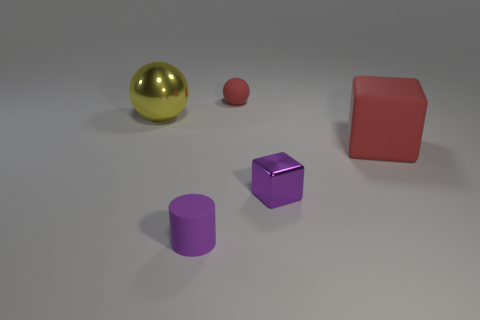Add 3 green metallic balls. How many objects exist? 8 Subtract 1 cylinders. How many cylinders are left? 0 Subtract all purple cubes. How many cubes are left? 1 Subtract 0 red cylinders. How many objects are left? 5 Subtract all blocks. How many objects are left? 3 Subtract all purple balls. Subtract all yellow cylinders. How many balls are left? 2 Subtract all blue spheres. How many purple cubes are left? 1 Subtract all purple cylinders. Subtract all metal blocks. How many objects are left? 3 Add 1 tiny purple cylinders. How many tiny purple cylinders are left? 2 Add 5 small brown cubes. How many small brown cubes exist? 5 